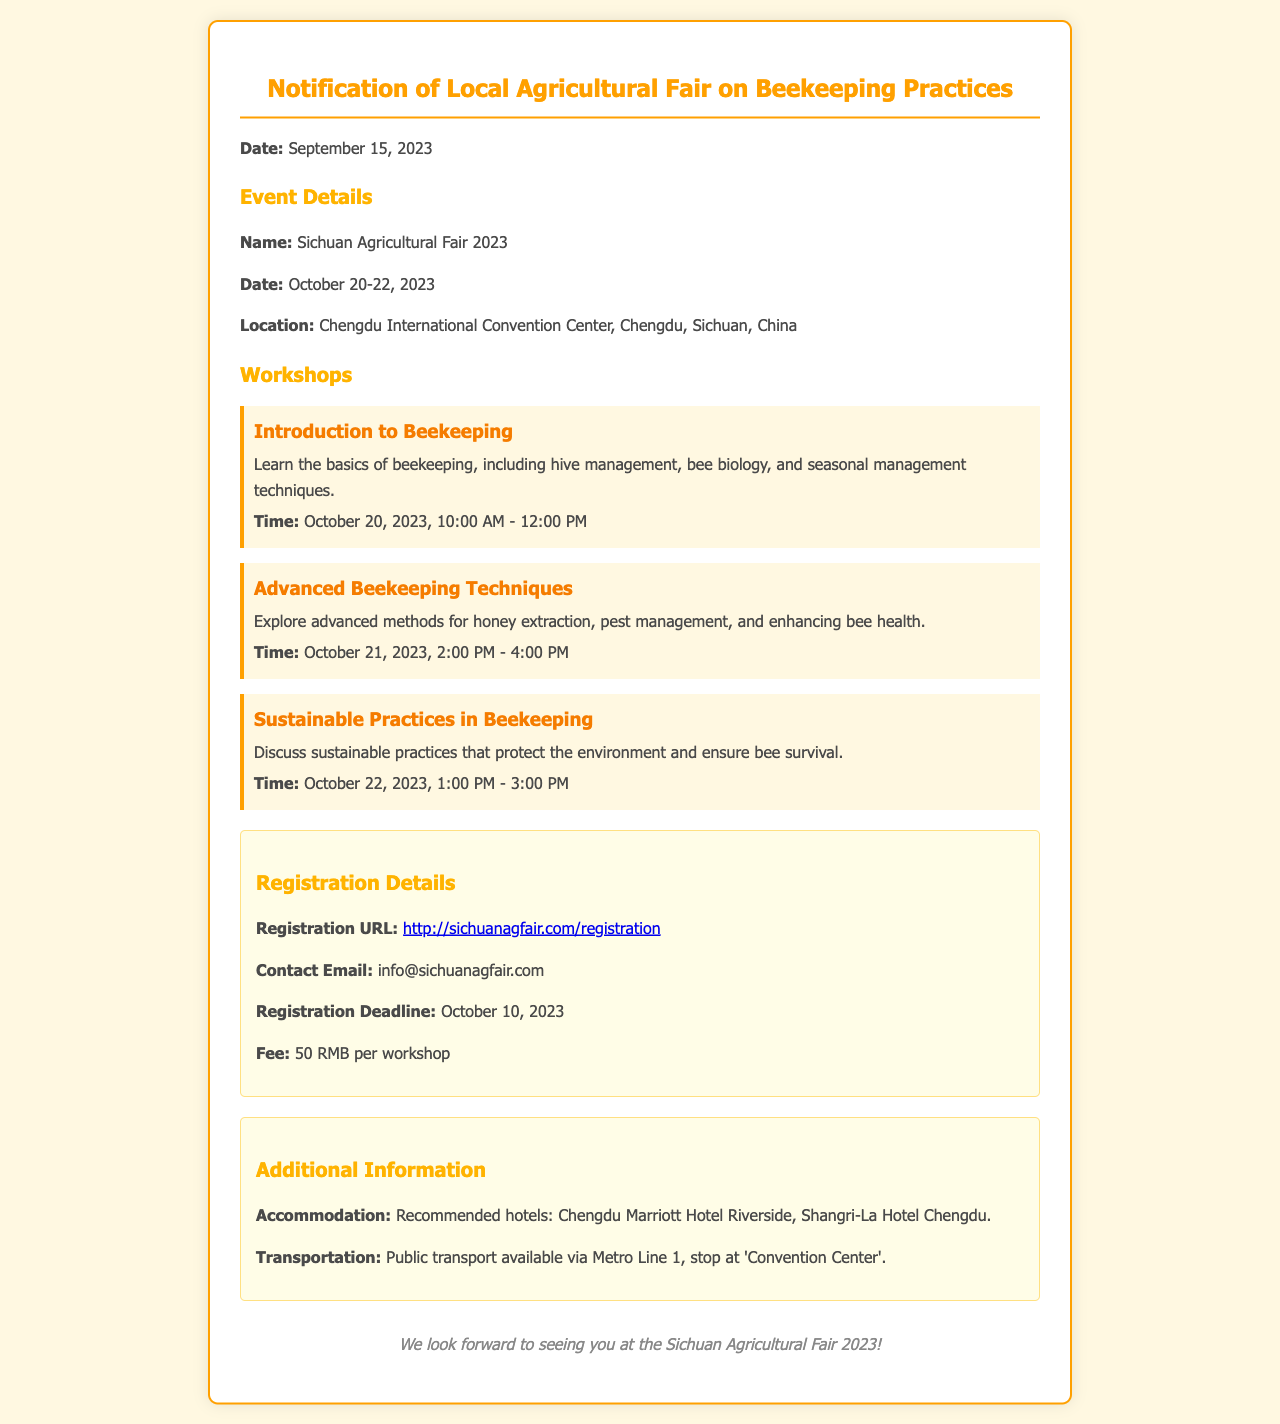What is the date of the agricultural fair? The document specifies that the Sichuan Agricultural Fair 2023 is scheduled for October 20-22, 2023.
Answer: October 20-22, 2023 What is the registration fee for each workshop? The document clearly states that the fee for each workshop is 50 RMB.
Answer: 50 RMB When is the deadline for registration? The document mentions that the registration deadline is October 10, 2023.
Answer: October 10, 2023 What is the location of the event? The event is held at the Chengdu International Convention Center, as indicated in the document.
Answer: Chengdu International Convention Center How many workshops are there listed in the document? The document lists three distinct workshops available during the fair.
Answer: Three What is the focus of the workshop on October 22? The workshop scheduled for October 22 focuses on sustainable practices in beekeeping.
Answer: Sustainable Practices in Beekeeping What method of transport is suggested in the document? The document indicates that public transport is available via Metro Line 1.
Answer: Metro Line 1 Where can you register for the event? The document provides a URL for registration: http://sichuanagfair.com/registration.
Answer: http://sichuanagfair.com/registration What is the contact email for inquiries? The document states that the contact email for the event is info@sichuanagfair.com.
Answer: info@sichuanagfair.com 